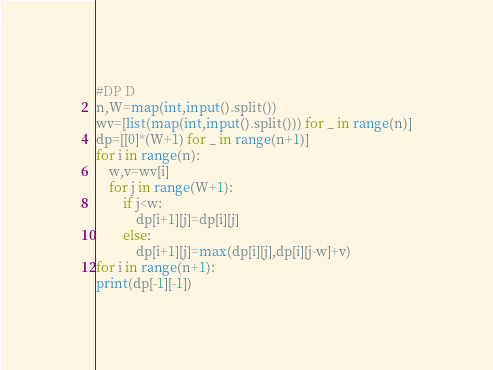<code> <loc_0><loc_0><loc_500><loc_500><_Python_>#DP D
n,W=map(int,input().split())
wv=[list(map(int,input().split())) for _ in range(n)]
dp=[[0]*(W+1) for _ in range(n+1)]
for i in range(n):
    w,v=wv[i]
    for j in range(W+1):
        if j<w:
            dp[i+1][j]=dp[i][j]
        else:
            dp[i+1][j]=max(dp[i][j],dp[i][j-w]+v)
for i in range(n+1):
print(dp[-1][-1])</code> 